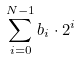<formula> <loc_0><loc_0><loc_500><loc_500>\sum _ { i = 0 } ^ { N - 1 } b _ { i } \cdot 2 ^ { i }</formula> 